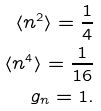<formula> <loc_0><loc_0><loc_500><loc_500>\langle n ^ { 2 } \rangle = \frac { 1 } { 4 } \\ \langle n ^ { 4 } \rangle = \frac { 1 } { 1 6 } \\ g _ { n } = 1 .</formula> 